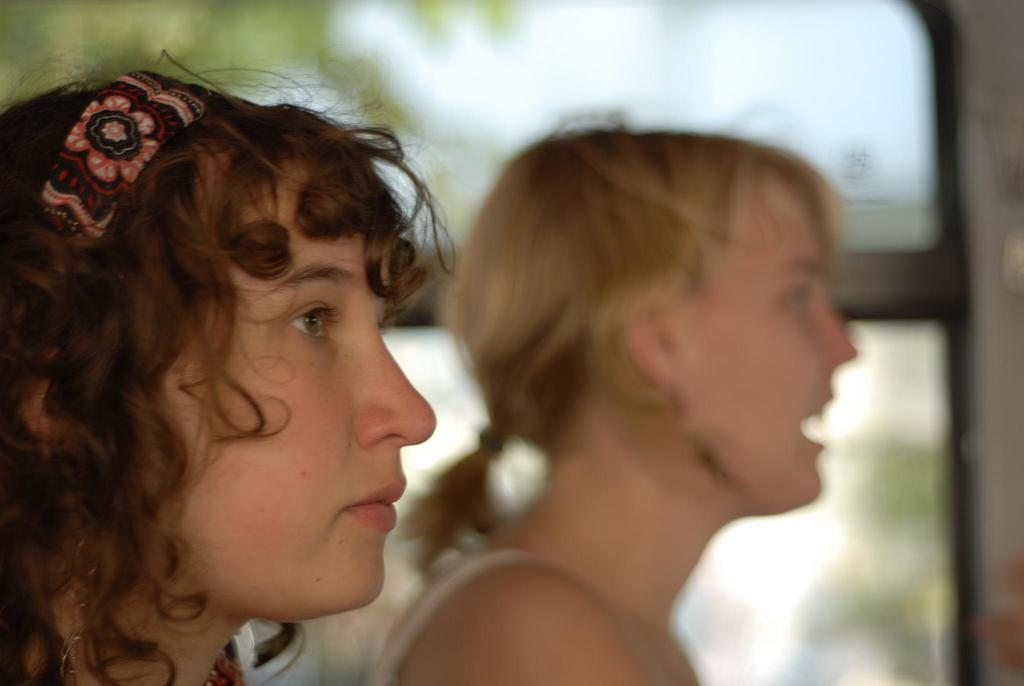What is the position of the woman in the image? There is a woman on the left side of the image. What is the woman on the left side wearing on her head? The woman on the left side is wearing a headband. Can you describe the other woman in the image? There is another woman in the middle of the image. What type of linen is being used to create the rail in the image? There is no rail present in the image, and therefore no linen can be associated with it. 